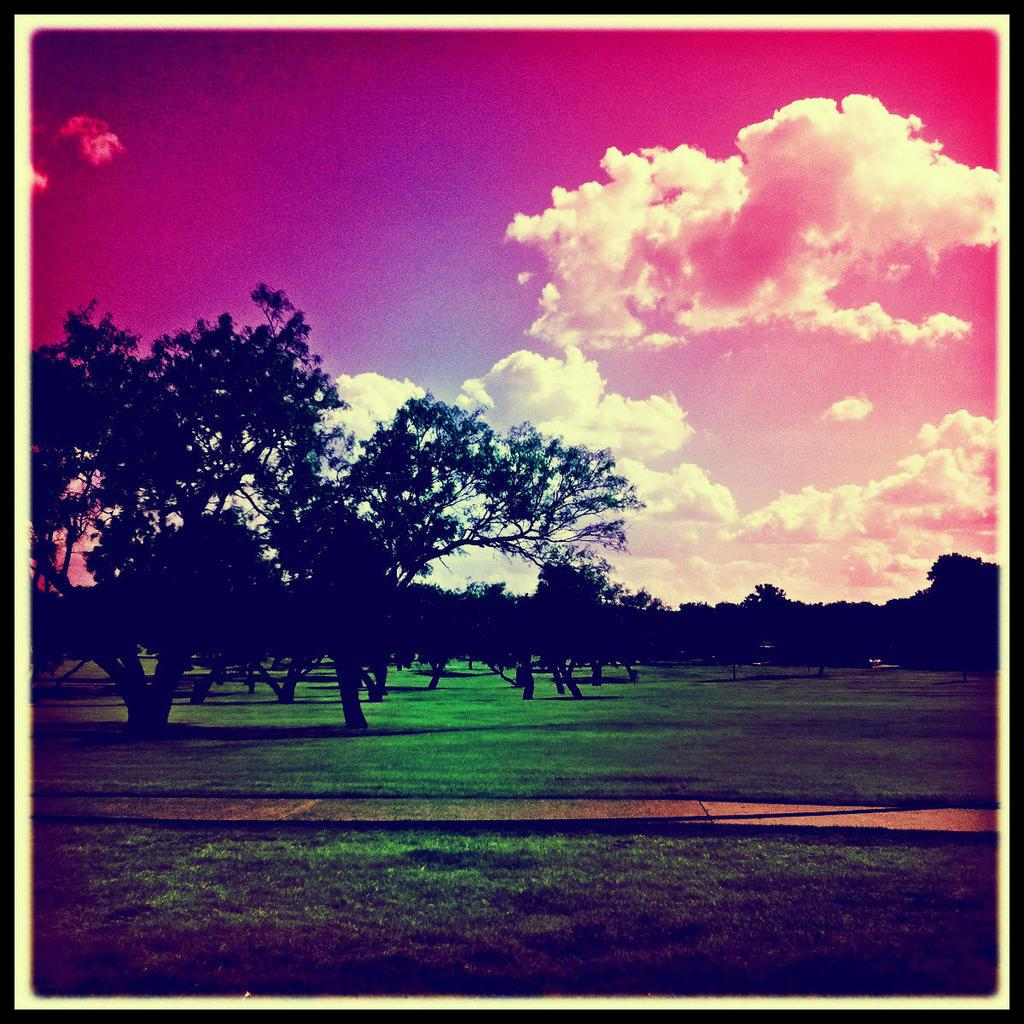What type of vegetation can be seen in the image? There are trees in the image. What is on the ground in the image? There is grass on the ground in the image. What is visible in the sky in the image? There are clouds in the sky. What is the color of the sky in the image? The sky has a pink color. Where is the cave located in the image? There is no cave present in the image. What type of food is being cooked in the image? There is no cooking activity depicted in the image. 